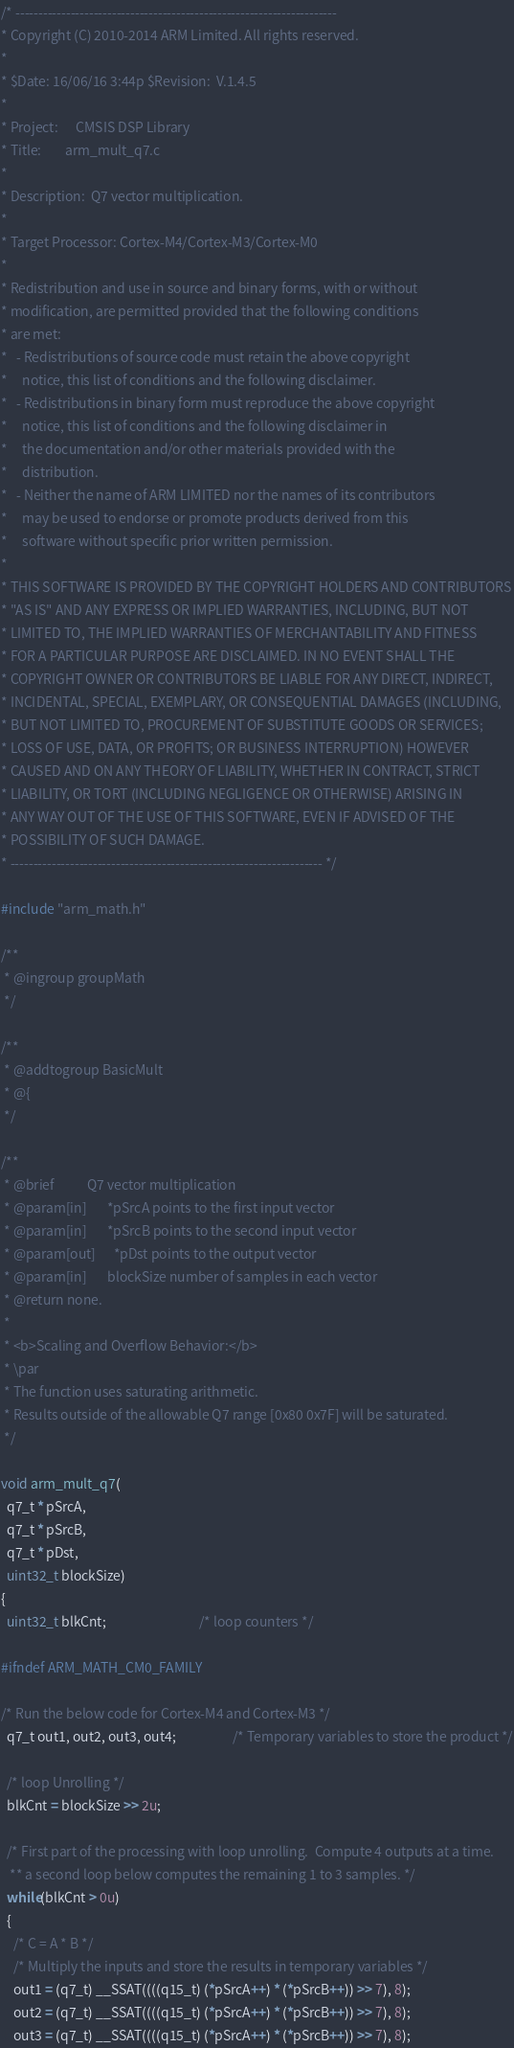Convert code to text. <code><loc_0><loc_0><loc_500><loc_500><_C_>/* ----------------------------------------------------------------------    
* Copyright (C) 2010-2014 ARM Limited. All rights reserved.    
*    
* $Date: 16/06/16 3:44p $Revision: 	V.1.4.5
*    
* Project: 	    CMSIS DSP Library    
* Title:	    arm_mult_q7.c    
*    
* Description:	Q7 vector multiplication.    
*    
* Target Processor: Cortex-M4/Cortex-M3/Cortex-M0
*  
* Redistribution and use in source and binary forms, with or without 
* modification, are permitted provided that the following conditions
* are met:
*   - Redistributions of source code must retain the above copyright
*     notice, this list of conditions and the following disclaimer.
*   - Redistributions in binary form must reproduce the above copyright
*     notice, this list of conditions and the following disclaimer in
*     the documentation and/or other materials provided with the 
*     distribution.
*   - Neither the name of ARM LIMITED nor the names of its contributors
*     may be used to endorse or promote products derived from this
*     software without specific prior written permission.
*
* THIS SOFTWARE IS PROVIDED BY THE COPYRIGHT HOLDERS AND CONTRIBUTORS
* "AS IS" AND ANY EXPRESS OR IMPLIED WARRANTIES, INCLUDING, BUT NOT
* LIMITED TO, THE IMPLIED WARRANTIES OF MERCHANTABILITY AND FITNESS
* FOR A PARTICULAR PURPOSE ARE DISCLAIMED. IN NO EVENT SHALL THE 
* COPYRIGHT OWNER OR CONTRIBUTORS BE LIABLE FOR ANY DIRECT, INDIRECT,
* INCIDENTAL, SPECIAL, EXEMPLARY, OR CONSEQUENTIAL DAMAGES (INCLUDING,
* BUT NOT LIMITED TO, PROCUREMENT OF SUBSTITUTE GOODS OR SERVICES;
* LOSS OF USE, DATA, OR PROFITS; OR BUSINESS INTERRUPTION) HOWEVER
* CAUSED AND ON ANY THEORY OF LIABILITY, WHETHER IN CONTRACT, STRICT
* LIABILITY, OR TORT (INCLUDING NEGLIGENCE OR OTHERWISE) ARISING IN
* ANY WAY OUT OF THE USE OF THIS SOFTWARE, EVEN IF ADVISED OF THE
* POSSIBILITY OF SUCH DAMAGE. 
* -------------------------------------------------------------------- */

#include "arm_math.h"

/**    
 * @ingroup groupMath    
 */

/**    
 * @addtogroup BasicMult    
 * @{    
 */

/**    
 * @brief           Q7 vector multiplication    
 * @param[in]       *pSrcA points to the first input vector    
 * @param[in]       *pSrcB points to the second input vector    
 * @param[out]      *pDst points to the output vector    
 * @param[in]       blockSize number of samples in each vector    
 * @return none.    
 *    
 * <b>Scaling and Overflow Behavior:</b>    
 * \par    
 * The function uses saturating arithmetic.    
 * Results outside of the allowable Q7 range [0x80 0x7F] will be saturated.    
 */

void arm_mult_q7(
  q7_t * pSrcA,
  q7_t * pSrcB,
  q7_t * pDst,
  uint32_t blockSize)
{
  uint32_t blkCnt;                               /* loop counters */

#ifndef ARM_MATH_CM0_FAMILY

/* Run the below code for Cortex-M4 and Cortex-M3 */
  q7_t out1, out2, out3, out4;                   /* Temporary variables to store the product */

  /* loop Unrolling */
  blkCnt = blockSize >> 2u;

  /* First part of the processing with loop unrolling.  Compute 4 outputs at a time.    
   ** a second loop below computes the remaining 1 to 3 samples. */
  while(blkCnt > 0u)
  {
    /* C = A * B */
    /* Multiply the inputs and store the results in temporary variables */
    out1 = (q7_t) __SSAT((((q15_t) (*pSrcA++) * (*pSrcB++)) >> 7), 8);
    out2 = (q7_t) __SSAT((((q15_t) (*pSrcA++) * (*pSrcB++)) >> 7), 8);
    out3 = (q7_t) __SSAT((((q15_t) (*pSrcA++) * (*pSrcB++)) >> 7), 8);</code> 